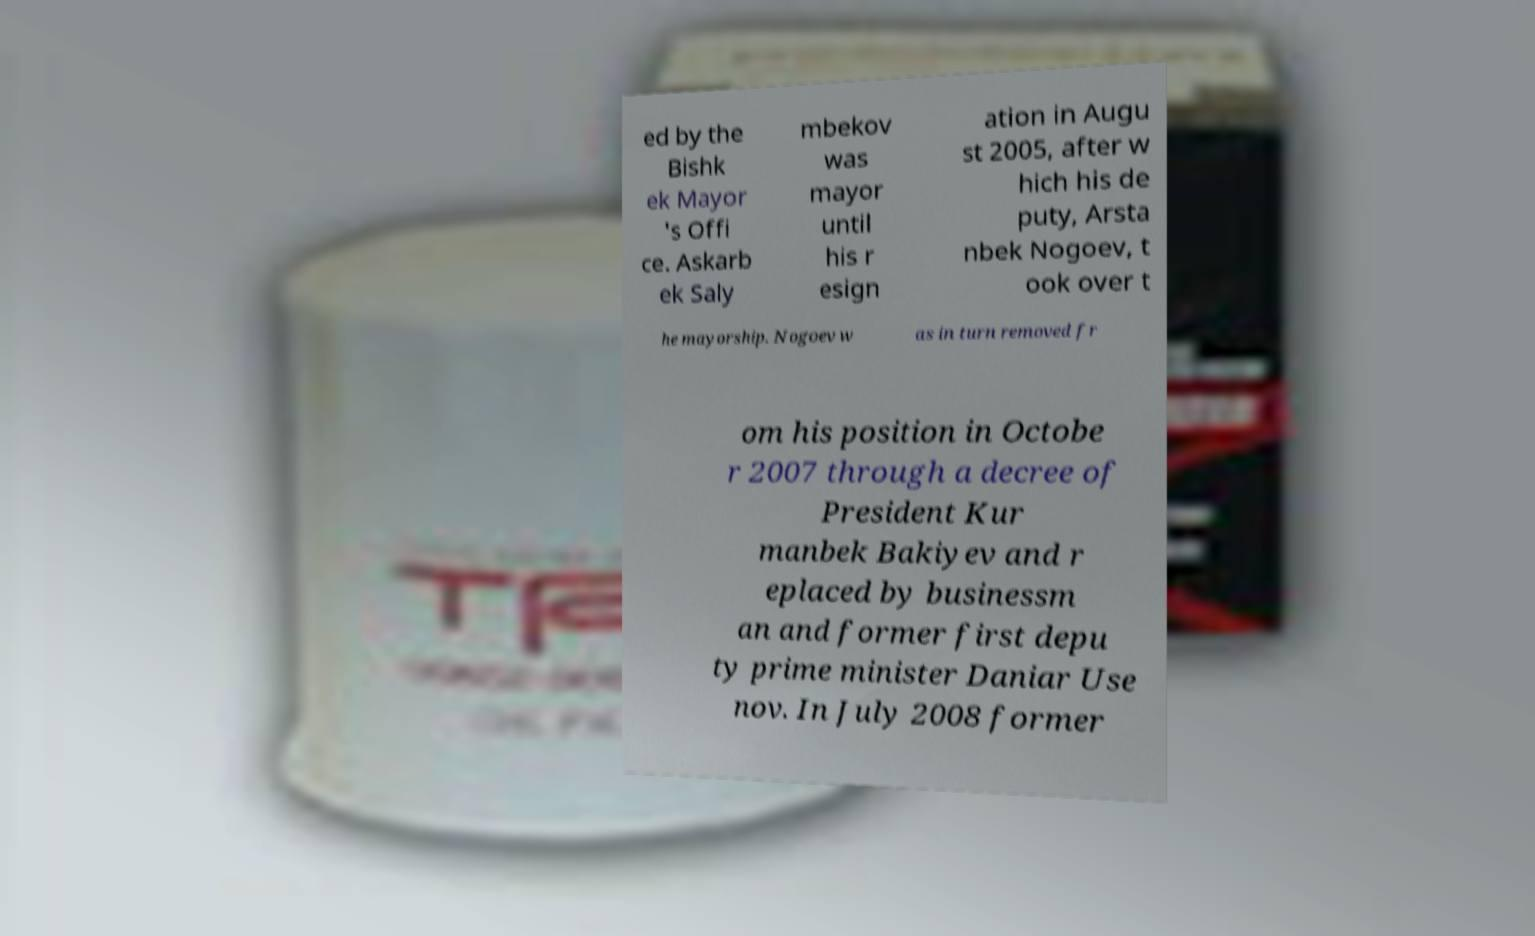Please identify and transcribe the text found in this image. ed by the Bishk ek Mayor 's Offi ce. Askarb ek Saly mbekov was mayor until his r esign ation in Augu st 2005, after w hich his de puty, Arsta nbek Nogoev, t ook over t he mayorship. Nogoev w as in turn removed fr om his position in Octobe r 2007 through a decree of President Kur manbek Bakiyev and r eplaced by businessm an and former first depu ty prime minister Daniar Use nov. In July 2008 former 